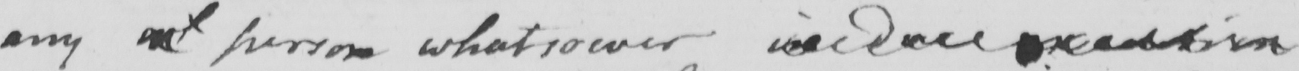Please transcribe the handwritten text in this image. any  <gap/>  person whatsoever in due execution 